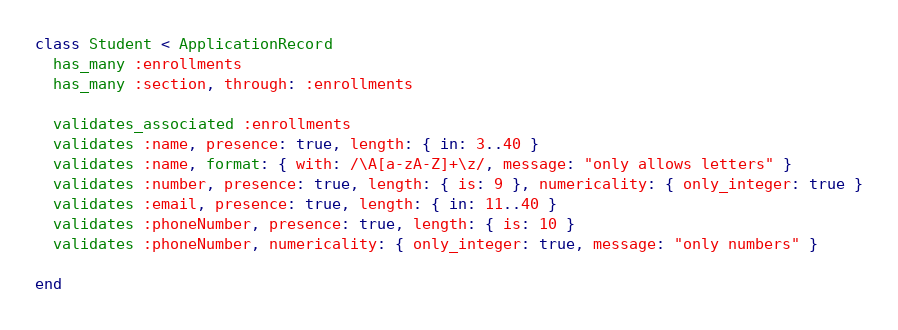Convert code to text. <code><loc_0><loc_0><loc_500><loc_500><_Ruby_>class Student < ApplicationRecord
  has_many :enrollments
  has_many :section, through: :enrollments

  validates_associated :enrollments
  validates :name, presence: true, length: { in: 3..40 }
  validates :name, format: { with: /\A[a-zA-Z]+\z/, message: "only allows letters" }
  validates :number, presence: true, length: { is: 9 }, numericality: { only_integer: true }
  validates :email, presence: true, length: { in: 11..40 }
  validates :phoneNumber, presence: true, length: { is: 10 }
  validates :phoneNumber, numericality: { only_integer: true, message: "only numbers" }

end
</code> 